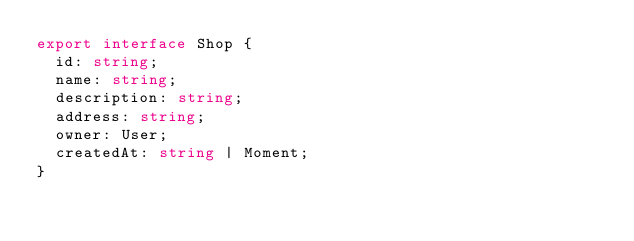Convert code to text. <code><loc_0><loc_0><loc_500><loc_500><_TypeScript_>export interface Shop {
  id: string;
  name: string;
  description: string;
  address: string;
  owner: User;
  createdAt: string | Moment;
}
</code> 